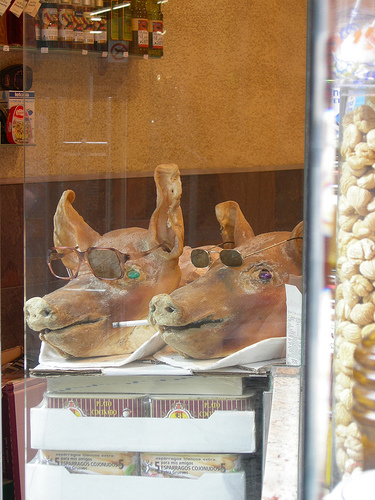<image>
Is the pigs in the sunglasses? Yes. The pigs is contained within or inside the sunglasses, showing a containment relationship. 